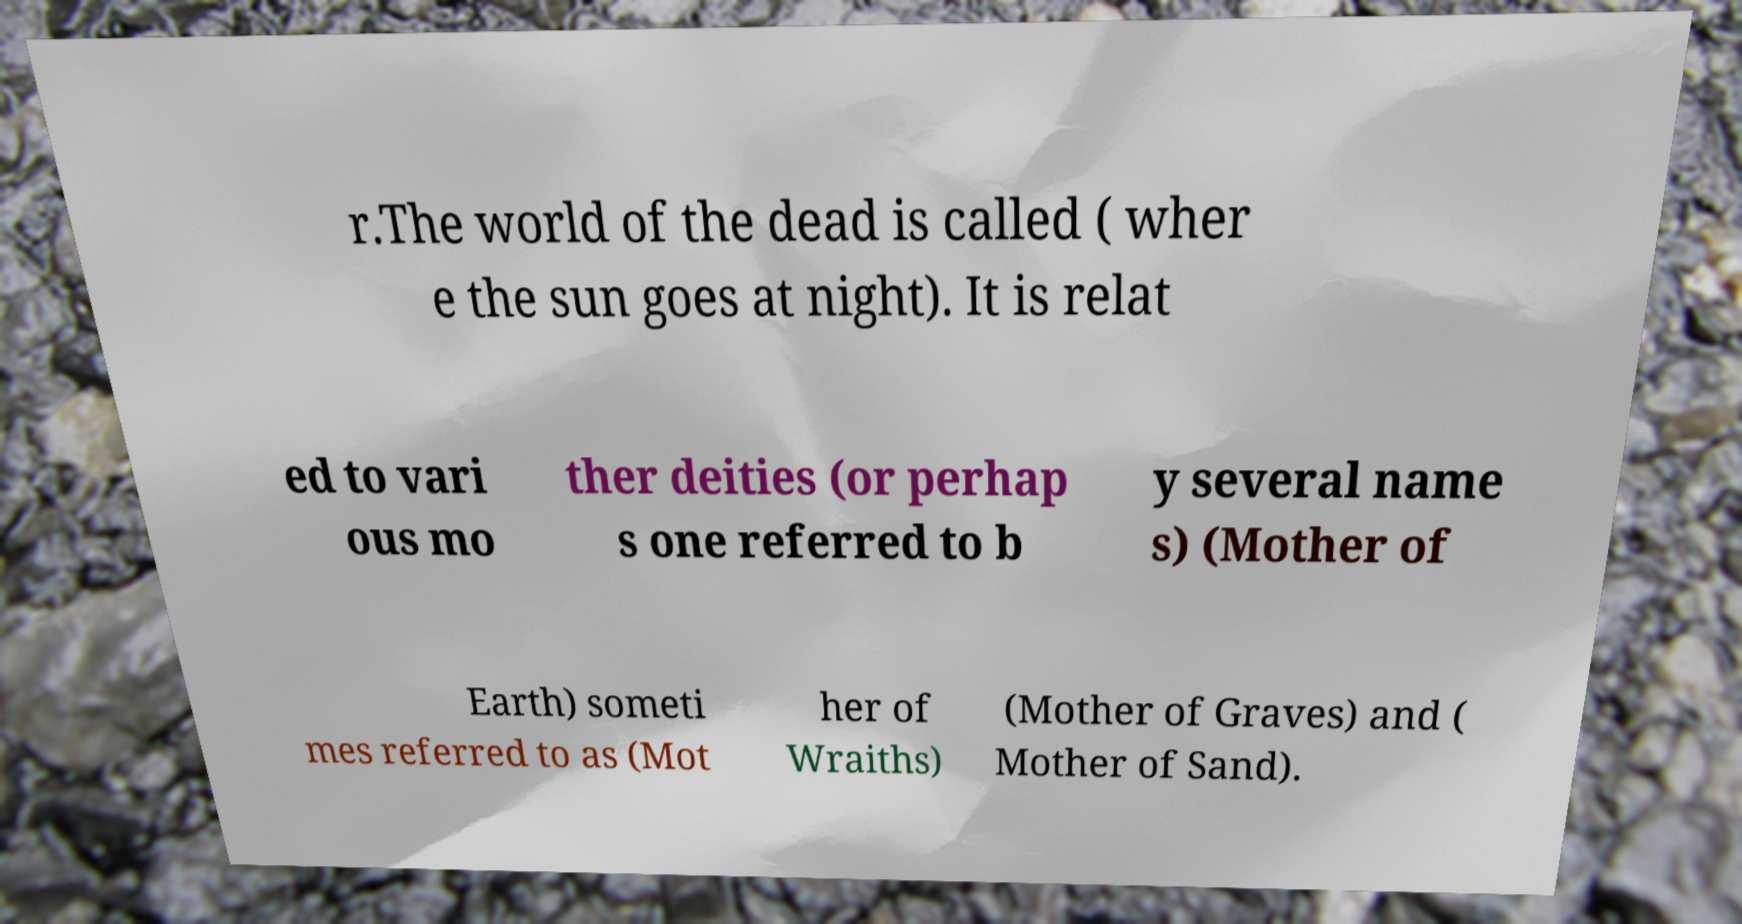For documentation purposes, I need the text within this image transcribed. Could you provide that? r.The world of the dead is called ( wher e the sun goes at night). It is relat ed to vari ous mo ther deities (or perhap s one referred to b y several name s) (Mother of Earth) someti mes referred to as (Mot her of Wraiths) (Mother of Graves) and ( Mother of Sand). 